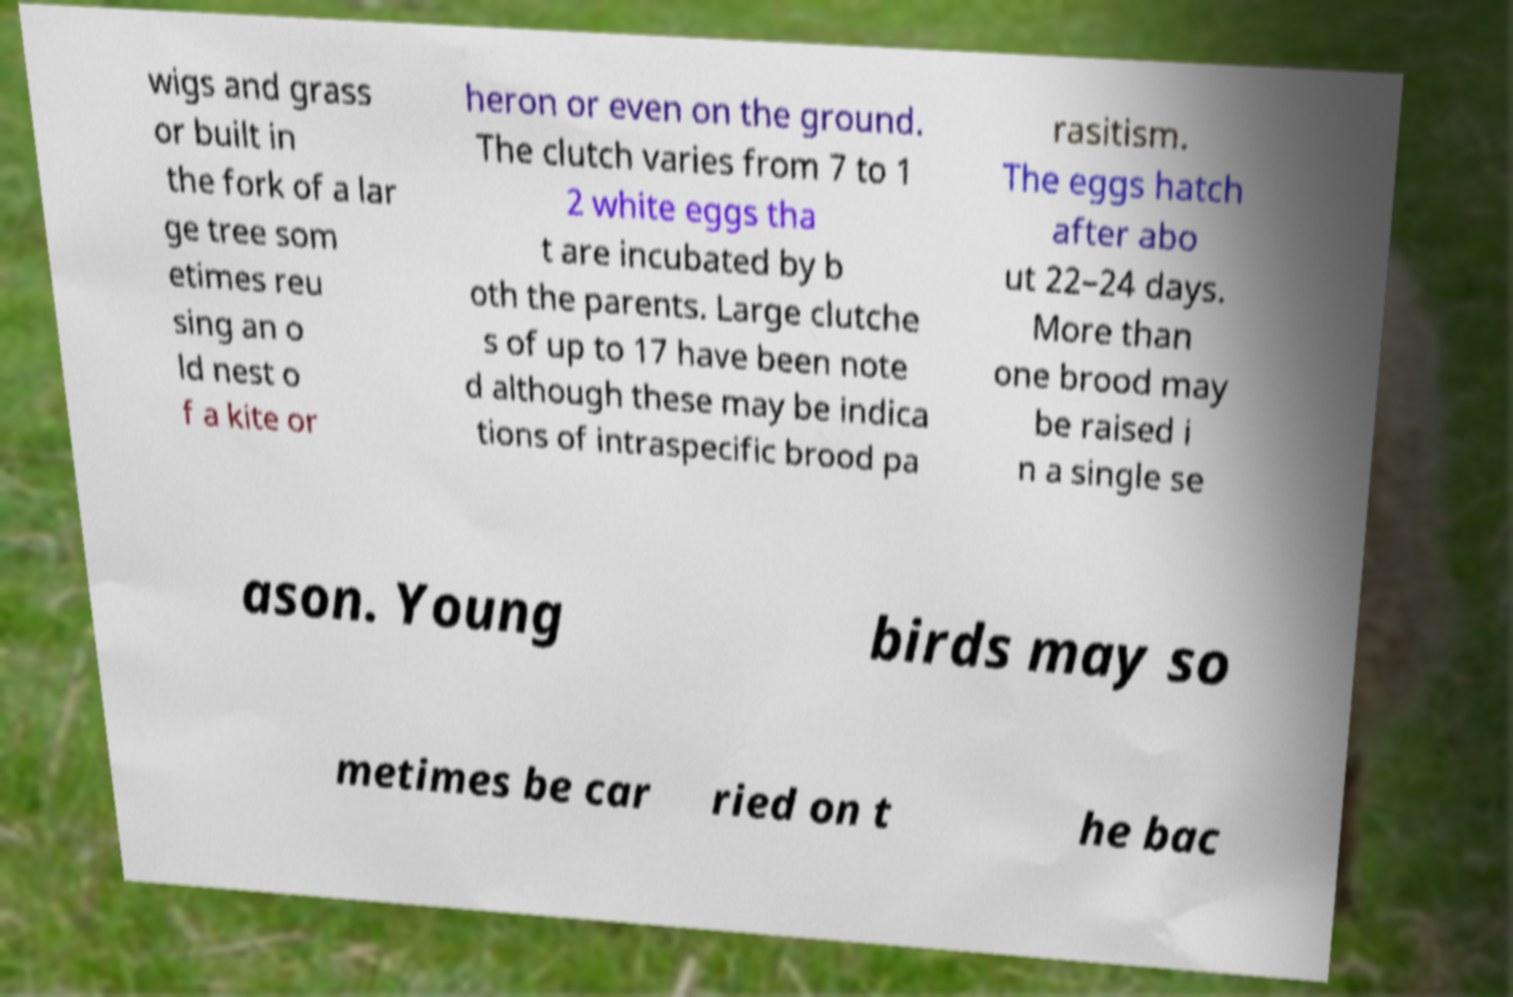There's text embedded in this image that I need extracted. Can you transcribe it verbatim? wigs and grass or built in the fork of a lar ge tree som etimes reu sing an o ld nest o f a kite or heron or even on the ground. The clutch varies from 7 to 1 2 white eggs tha t are incubated by b oth the parents. Large clutche s of up to 17 have been note d although these may be indica tions of intraspecific brood pa rasitism. The eggs hatch after abo ut 22–24 days. More than one brood may be raised i n a single se ason. Young birds may so metimes be car ried on t he bac 